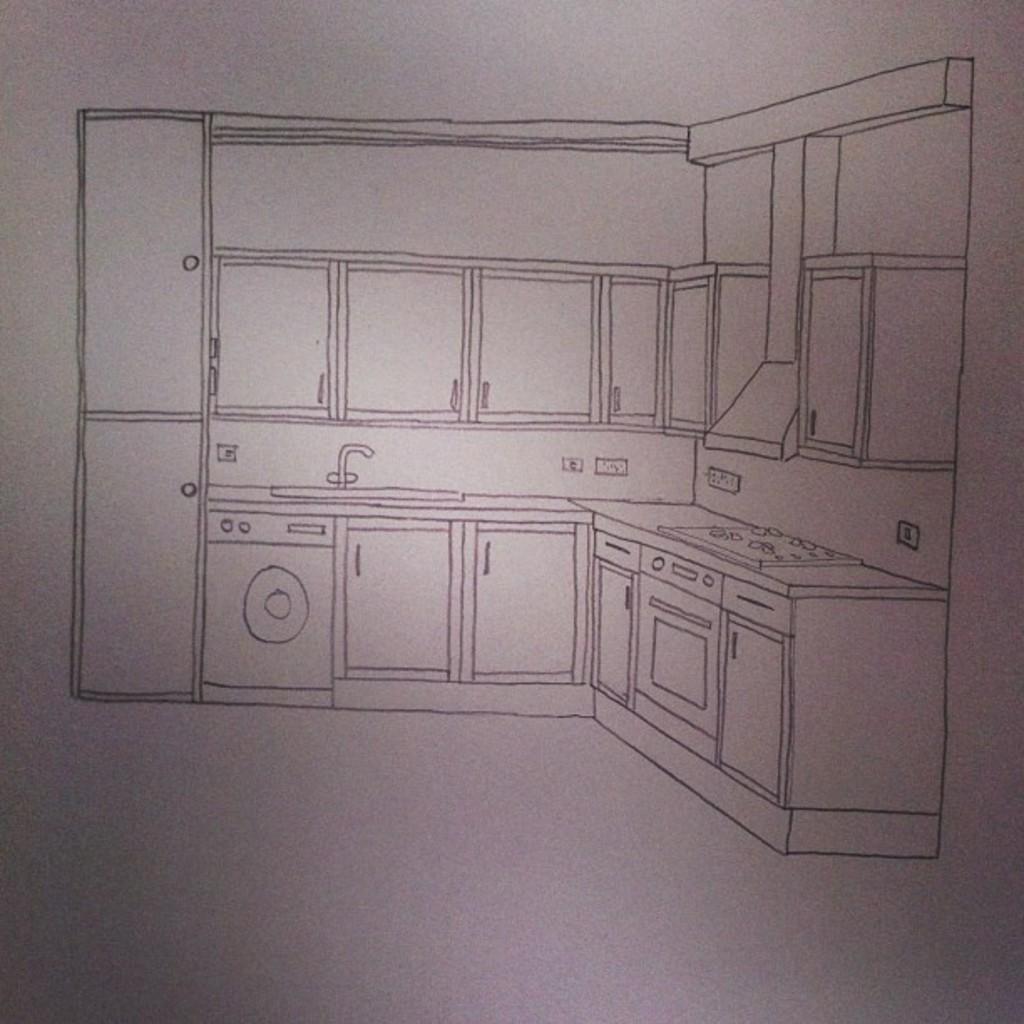Could you give a brief overview of what you see in this image? In this image I can see drawing of a kitchen. 